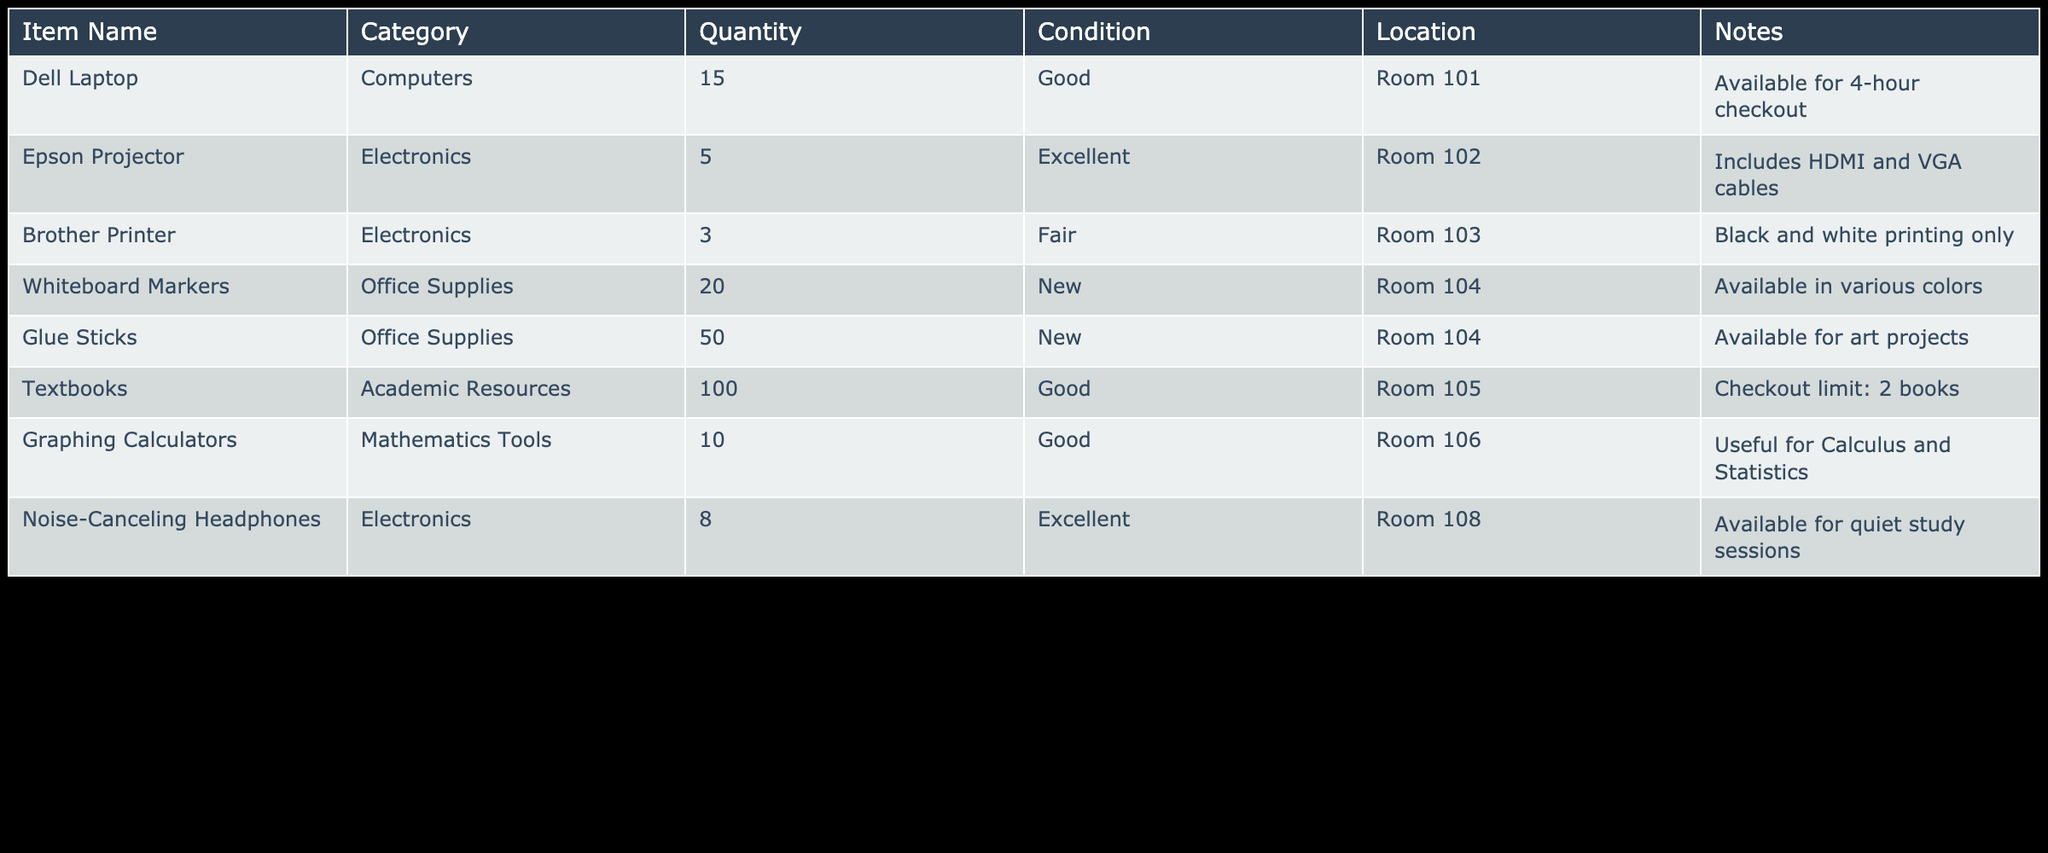What's the total quantity of office supplies available? The office supplies listed are Whiteboard Markers (20) and Glue Sticks (50). Adding these together gives 20 + 50 = 70.
Answer: 70 How many laptops are available in good condition? There are 15 Dell Laptops listed in the table, and the condition is 'Good'. Therefore, the total quantity of laptops in good condition is 15.
Answer: 15 Is the Brother Printer available in excellent condition? The condition of the Brother Printer is stated as 'Fair', which means it is not in excellent condition.
Answer: No What is the total number of electronics available? The electronics listed are 5 Epson Projectors, 3 Brother Printers, and 8 Noise-Canceling Headphones. Adding these quantities gives 5 + 3 + 8 = 16.
Answer: 16 Which item has the highest quantity and how many? The item with the highest quantity is Glue Sticks with a total of 50 available. To confirm, we compare the quantities of all items listed: Dell Laptop (15), Epson Projector (5), Brother Printer (3), Whiteboard Markers (20), Glue Sticks (50), Textbooks (100), Graphing Calculators (10), and Noise-Canceling Headphones (8). The highest is Glue Sticks at 50.
Answer: 50 Are there more than 10 Graphing Calculators available? There are a total of 10 Graphing Calculators available. Since 10 is not greater than 10, the answer is no.
Answer: No What percentage of the total number of items are Textbooks? The total number of items is calculated by summing all quantities: 15 (Laptops) + 5 (Projectors) + 3 (Printers) + 20 (Markers) + 50 (Glue Sticks) + 100 (Textbooks) + 10 (Calculators) + 8 (Headphones) = 211. The percentage of Textbooks is then (100 / 211) * 100 = approximately 47.4%.
Answer: 47.4% How many items are in the resource center that can be checked out for fewer than 4 hours? Only the Glue Sticks and Whiteboard Markers are listed for more flexible accessibility. Laptops are available for 4-hour checkout, so they do not count. Thus, the total is 50 (Glue Sticks) + 20 (Whiteboard Markers) = 70.
Answer: 70 Which category has the fewest items available? The Brother Printer has the fewest quantity at 3, which compares against the other categories: Computers (15), Electronics (16), Office Supplies (70), Academic Resources (100), and Mathematics Tools (10). Therefore, Brother Printers, with a quantity of 3, is the lowest.
Answer: 3 